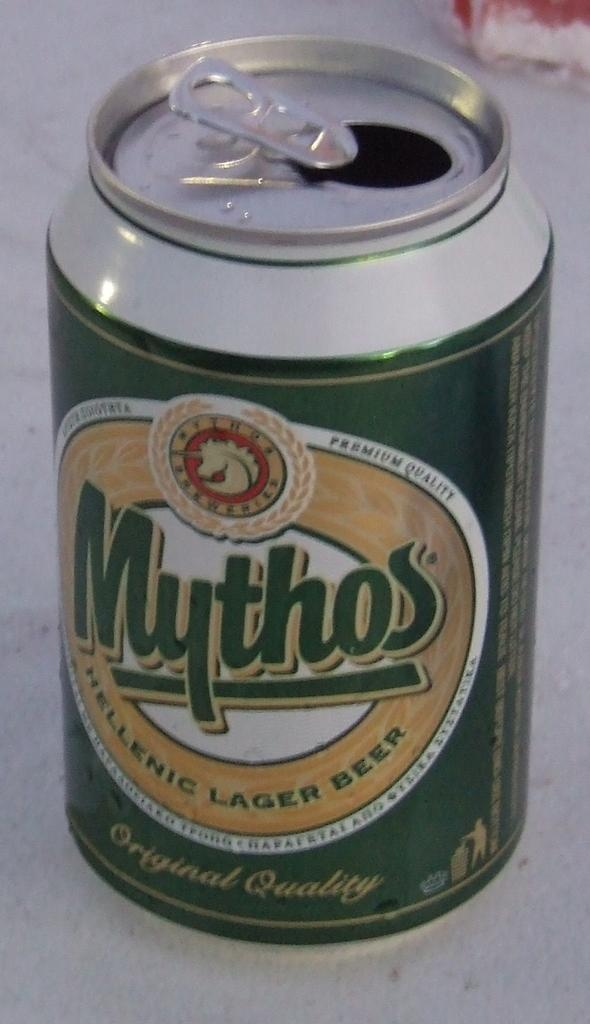<image>
Summarize the visual content of the image. a mythos can that is green in color 